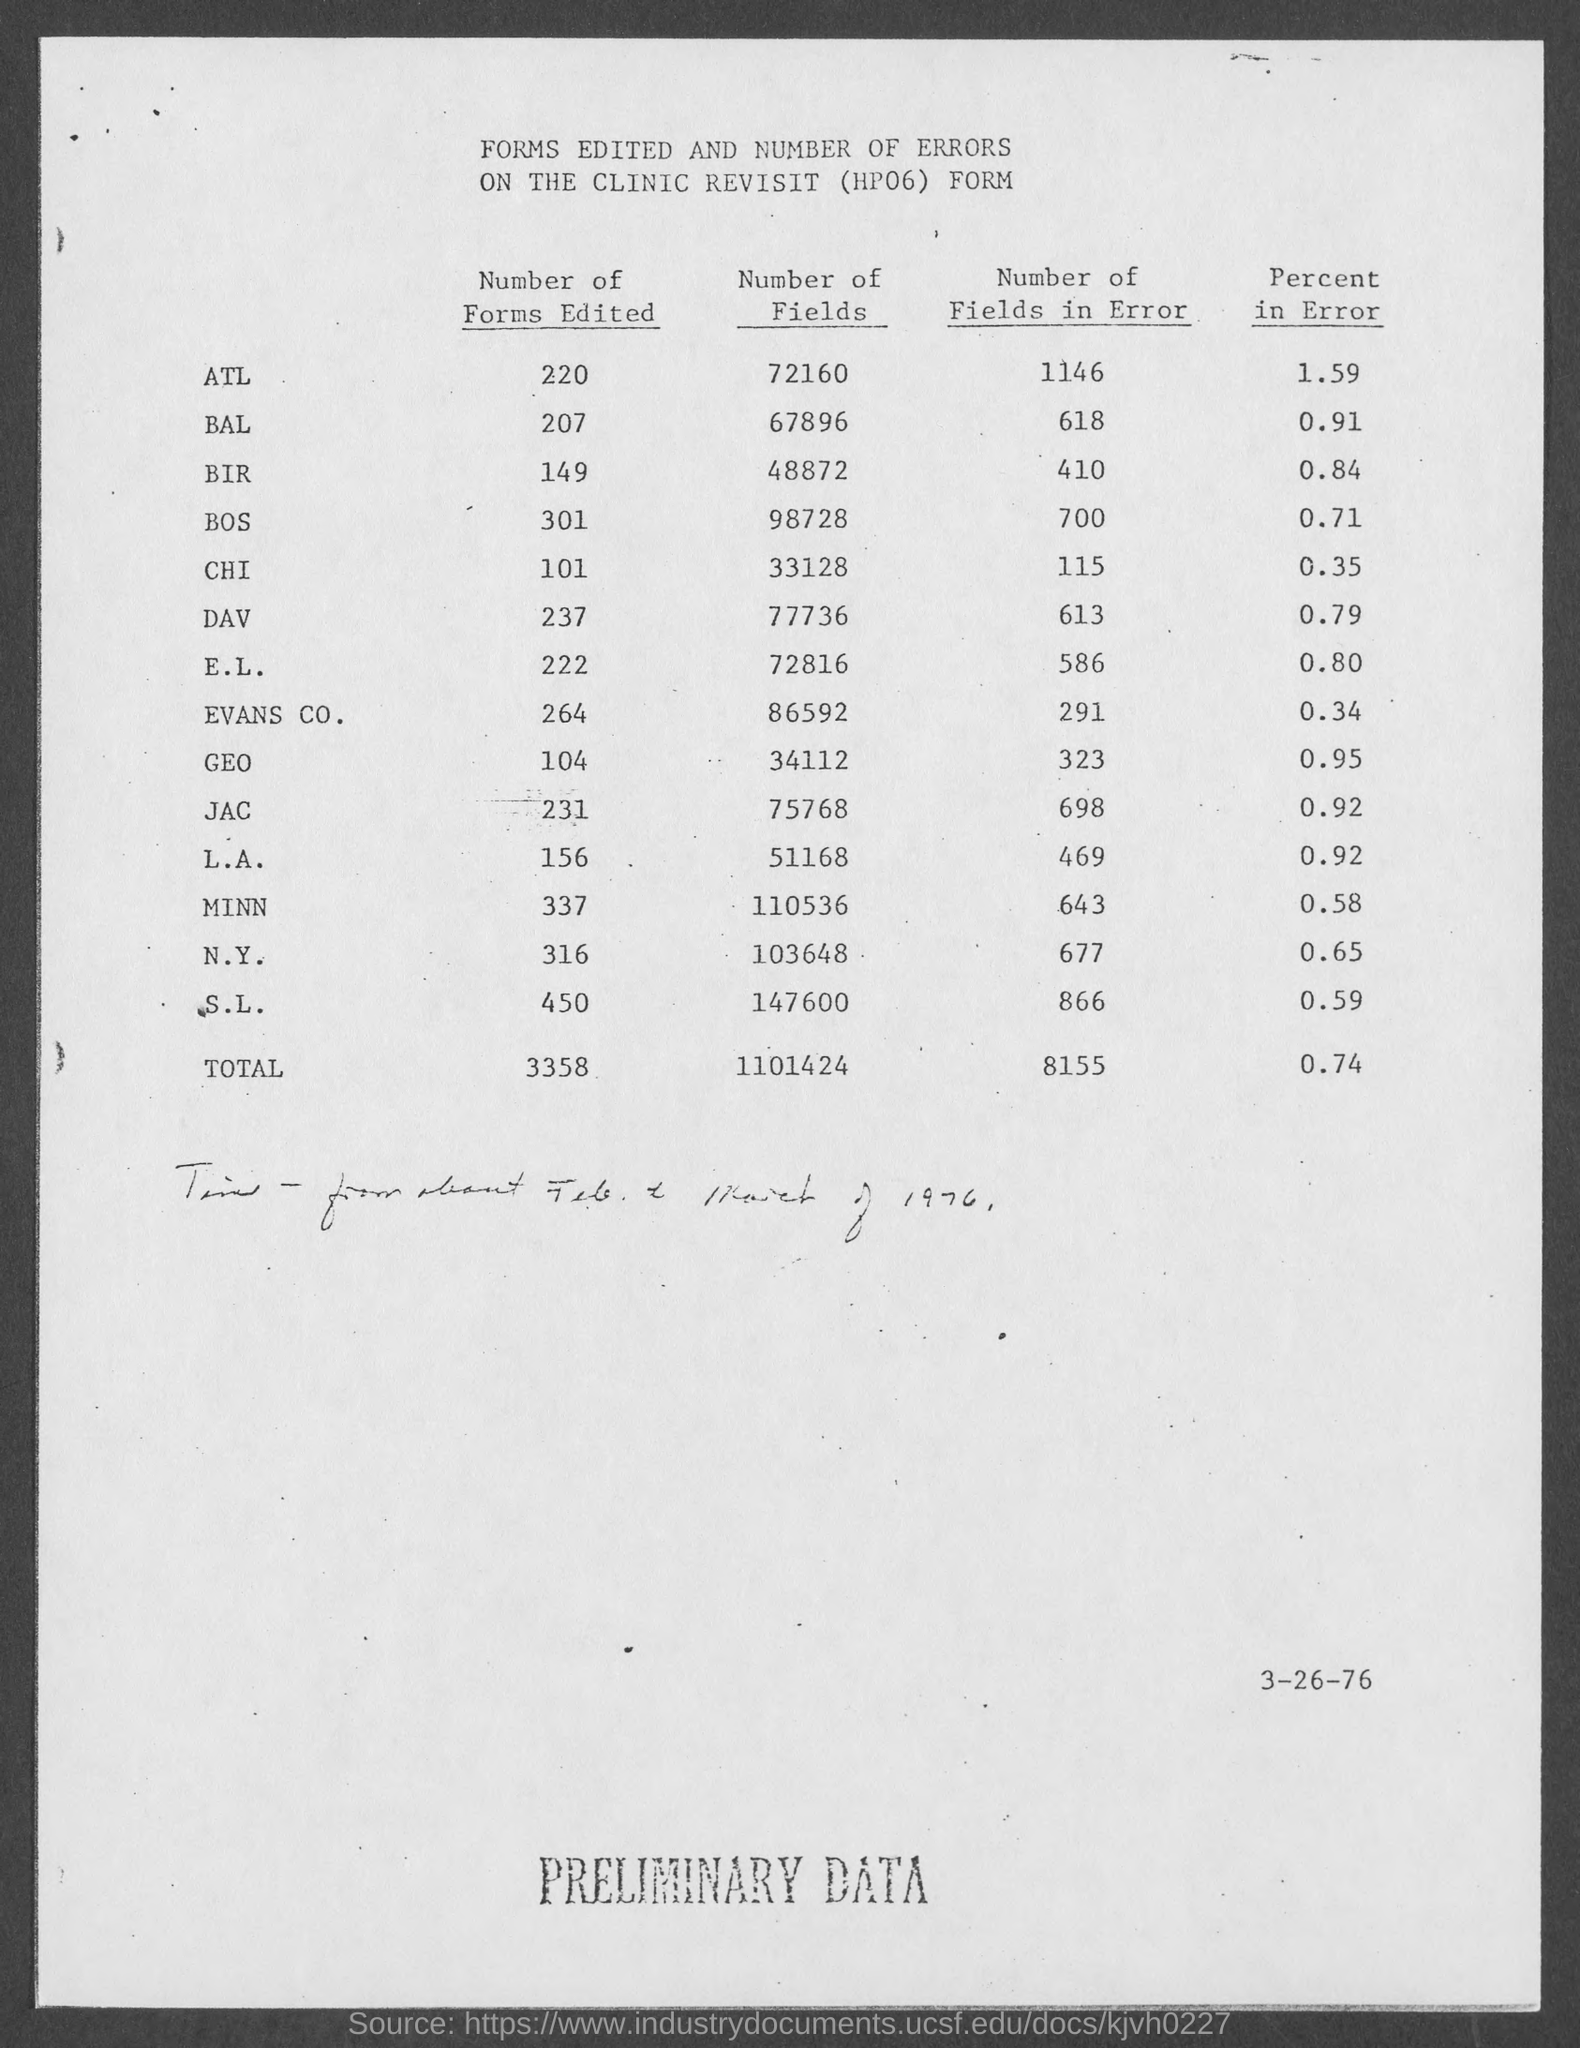Draw attention to some important aspects in this diagram. It is edited 220 forms of ATL. The number of fields in DAV that have errors is 613. The percent of error of JAC is 0.92%. The quantity of fields for BAL is 67896. A total of 3358 forms have been edited. 